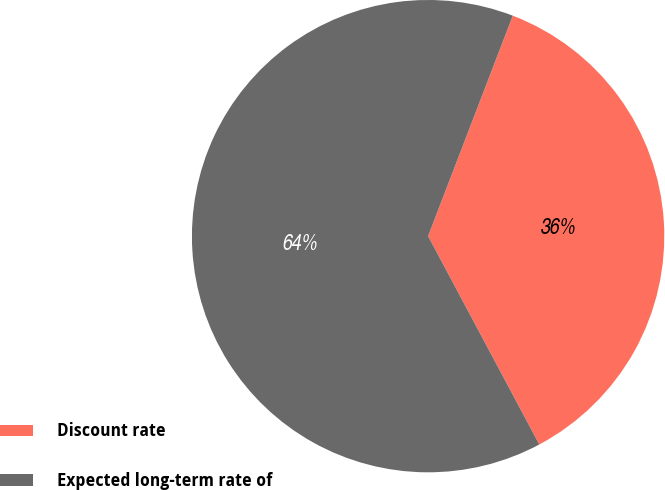<chart> <loc_0><loc_0><loc_500><loc_500><pie_chart><fcel>Discount rate<fcel>Expected long-term rate of<nl><fcel>36.36%<fcel>63.64%<nl></chart> 